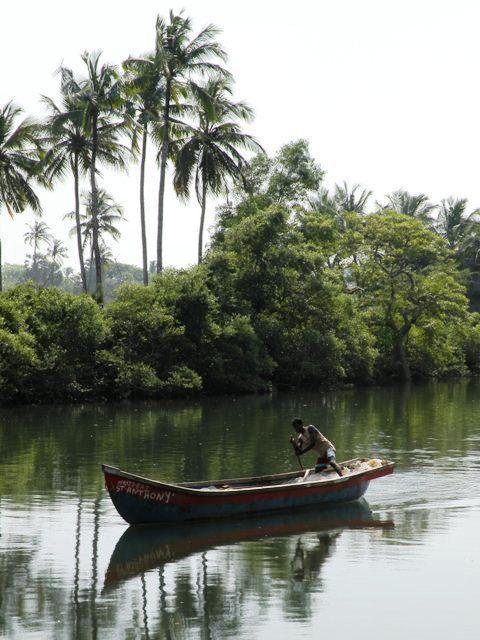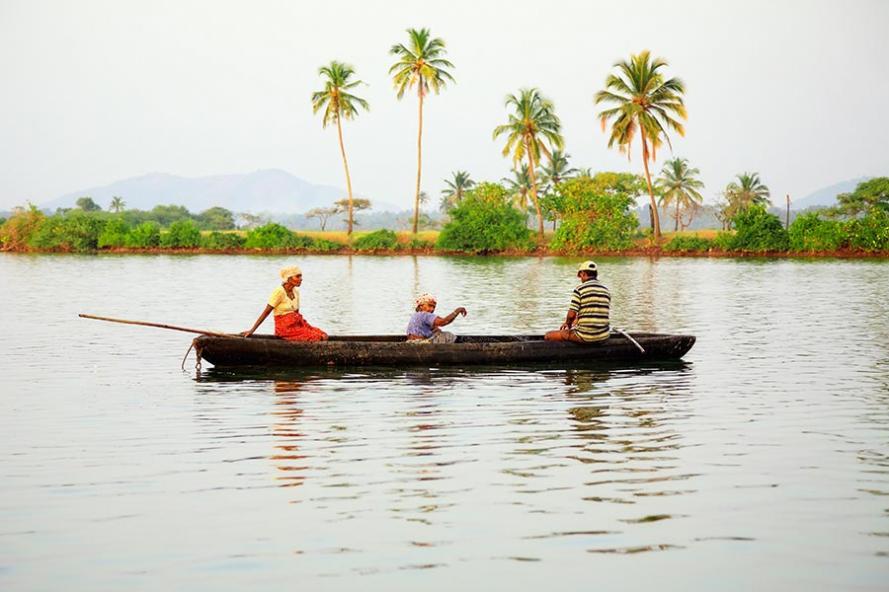The first image is the image on the left, the second image is the image on the right. Assess this claim about the two images: "An image includes three people in one canoe on the water.". Correct or not? Answer yes or no. Yes. The first image is the image on the left, the second image is the image on the right. Considering the images on both sides, is "In one image, three people, two of them using or sitting near oars, can be seen in a single canoe in a body of water near a shoreline with trees," valid? Answer yes or no. Yes. 